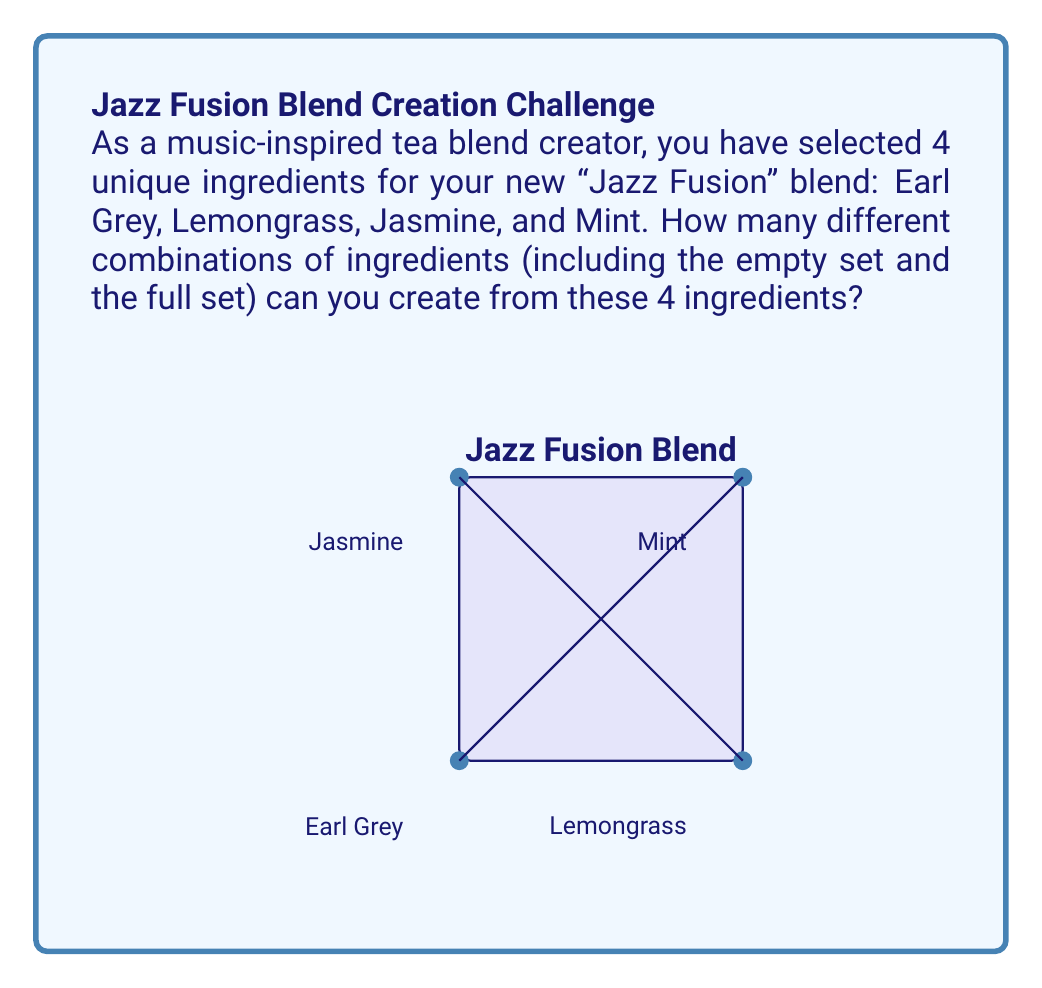Help me with this question. To solve this problem, we need to understand the concept of a power set. The power set of a set S is the set of all subsets of S, including the empty set and S itself.

Let's approach this step-by-step:

1) First, let's list our ingredients:
   $S = \{Earl Grey, Lemongrass, Jasmine, Mint\}$

2) The number of elements in S is 4. Let's call this $n = 4$.

3) For any set with $n$ elements, the number of subsets (i.e., the cardinality of the power set) is given by the formula:

   $|P(S)| = 2^n$

4) This is because for each element, we have two choices: either include it in the subset or not. And we make this choice independently for each element.

5) In our case:
   $|P(S)| = 2^4 = 16$

6) We can verify this by listing all possible subsets:
   - Empty set: $\{\}$
   - Single ingredient sets: $\{Earl Grey\}$, $\{Lemongrass\}$, $\{Jasmine\}$, $\{Mint\}$
   - Two ingredient sets: $\{Earl Grey, Lemongrass\}$, $\{Earl Grey, Jasmine\}$, $\{Earl Grey, Mint\}$, $\{Lemongrass, Jasmine\}$, $\{Lemongrass, Mint\}$, $\{Jasmine, Mint\}$
   - Three ingredient sets: $\{Earl Grey, Lemongrass, Jasmine\}$, $\{Earl Grey, Lemongrass, Mint\}$, $\{Earl Grey, Jasmine, Mint\}$, $\{Lemongrass, Jasmine, Mint\}$
   - Full set: $\{Earl Grey, Lemongrass, Jasmine, Mint\}$

Indeed, we have 16 different combinations in total.
Answer: $2^4 = 16$ combinations 